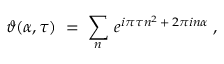<formula> <loc_0><loc_0><loc_500><loc_500>\vartheta ( \alpha , \tau ) \, = \, \sum _ { n } \, e ^ { i \pi \tau n ^ { 2 } \, + \, 2 \pi i n \alpha } \, ,</formula> 